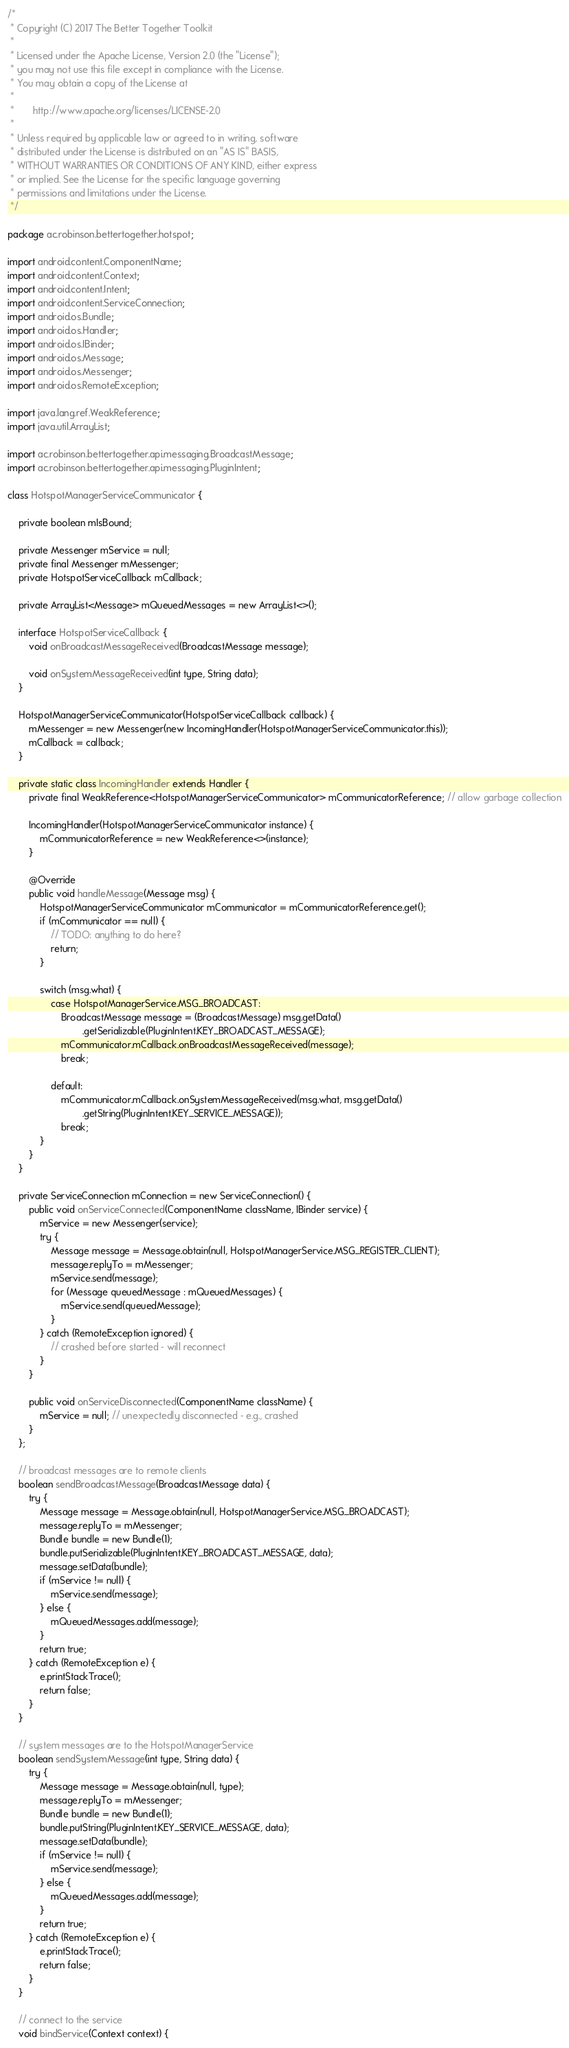Convert code to text. <code><loc_0><loc_0><loc_500><loc_500><_Java_>/*
 * Copyright (C) 2017 The Better Together Toolkit
 *
 * Licensed under the Apache License, Version 2.0 (the "License");
 * you may not use this file except in compliance with the License.
 * You may obtain a copy of the License at
 *
 *       http://www.apache.org/licenses/LICENSE-2.0
 *
 * Unless required by applicable law or agreed to in writing, software
 * distributed under the License is distributed on an "AS IS" BASIS,
 * WITHOUT WARRANTIES OR CONDITIONS OF ANY KIND, either express
 * or implied. See the License for the specific language governing
 * permissions and limitations under the License.
 */

package ac.robinson.bettertogether.hotspot;

import android.content.ComponentName;
import android.content.Context;
import android.content.Intent;
import android.content.ServiceConnection;
import android.os.Bundle;
import android.os.Handler;
import android.os.IBinder;
import android.os.Message;
import android.os.Messenger;
import android.os.RemoteException;

import java.lang.ref.WeakReference;
import java.util.ArrayList;

import ac.robinson.bettertogether.api.messaging.BroadcastMessage;
import ac.robinson.bettertogether.api.messaging.PluginIntent;

class HotspotManagerServiceCommunicator {

	private boolean mIsBound;

	private Messenger mService = null;
	private final Messenger mMessenger;
	private HotspotServiceCallback mCallback;

	private ArrayList<Message> mQueuedMessages = new ArrayList<>();

	interface HotspotServiceCallback {
		void onBroadcastMessageReceived(BroadcastMessage message);

		void onSystemMessageReceived(int type, String data);
	}

	HotspotManagerServiceCommunicator(HotspotServiceCallback callback) {
		mMessenger = new Messenger(new IncomingHandler(HotspotManagerServiceCommunicator.this));
		mCallback = callback;
	}

	private static class IncomingHandler extends Handler {
		private final WeakReference<HotspotManagerServiceCommunicator> mCommunicatorReference; // allow garbage collection

		IncomingHandler(HotspotManagerServiceCommunicator instance) {
			mCommunicatorReference = new WeakReference<>(instance);
		}

		@Override
		public void handleMessage(Message msg) {
			HotspotManagerServiceCommunicator mCommunicator = mCommunicatorReference.get();
			if (mCommunicator == null) {
				// TODO: anything to do here?
				return;
			}

			switch (msg.what) {
				case HotspotManagerService.MSG_BROADCAST:
					BroadcastMessage message = (BroadcastMessage) msg.getData()
							.getSerializable(PluginIntent.KEY_BROADCAST_MESSAGE);
					mCommunicator.mCallback.onBroadcastMessageReceived(message);
					break;

				default:
					mCommunicator.mCallback.onSystemMessageReceived(msg.what, msg.getData()
							.getString(PluginIntent.KEY_SERVICE_MESSAGE));
					break;
			}
		}
	}

	private ServiceConnection mConnection = new ServiceConnection() {
		public void onServiceConnected(ComponentName className, IBinder service) {
			mService = new Messenger(service);
			try {
				Message message = Message.obtain(null, HotspotManagerService.MSG_REGISTER_CLIENT);
				message.replyTo = mMessenger;
				mService.send(message);
				for (Message queuedMessage : mQueuedMessages) {
					mService.send(queuedMessage);
				}
			} catch (RemoteException ignored) {
				// crashed before started - will reconnect
			}
		}

		public void onServiceDisconnected(ComponentName className) {
			mService = null; // unexpectedly disconnected - e.g., crashed
		}
	};

	// broadcast messages are to remote clients
	boolean sendBroadcastMessage(BroadcastMessage data) {
		try {
			Message message = Message.obtain(null, HotspotManagerService.MSG_BROADCAST);
			message.replyTo = mMessenger;
			Bundle bundle = new Bundle(1);
			bundle.putSerializable(PluginIntent.KEY_BROADCAST_MESSAGE, data);
			message.setData(bundle);
			if (mService != null) {
				mService.send(message);
			} else {
				mQueuedMessages.add(message);
			}
			return true;
		} catch (RemoteException e) {
			e.printStackTrace();
			return false;
		}
	}

	// system messages are to the HotspotManagerService
	boolean sendSystemMessage(int type, String data) {
		try {
			Message message = Message.obtain(null, type);
			message.replyTo = mMessenger;
			Bundle bundle = new Bundle(1);
			bundle.putString(PluginIntent.KEY_SERVICE_MESSAGE, data);
			message.setData(bundle);
			if (mService != null) {
				mService.send(message);
			} else {
				mQueuedMessages.add(message);
			}
			return true;
		} catch (RemoteException e) {
			e.printStackTrace();
			return false;
		}
	}

	// connect to the service
	void bindService(Context context) {</code> 